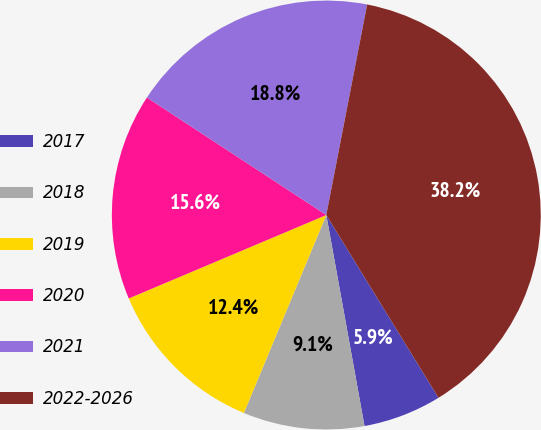Convert chart. <chart><loc_0><loc_0><loc_500><loc_500><pie_chart><fcel>2017<fcel>2018<fcel>2019<fcel>2020<fcel>2021<fcel>2022-2026<nl><fcel>5.91%<fcel>9.13%<fcel>12.36%<fcel>15.59%<fcel>18.82%<fcel>38.19%<nl></chart> 